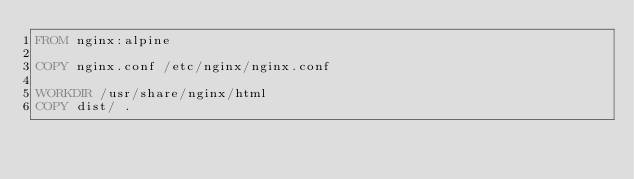Convert code to text. <code><loc_0><loc_0><loc_500><loc_500><_Dockerfile_>FROM nginx:alpine

COPY nginx.conf /etc/nginx/nginx.conf

WORKDIR /usr/share/nginx/html
COPY dist/ .</code> 